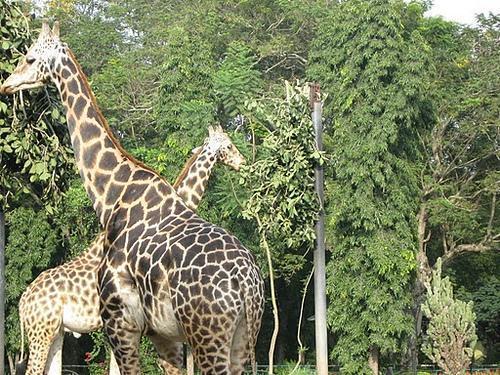How many giraffes are there?
Give a very brief answer. 2. How many food poles for the giraffes are there?
Give a very brief answer. 2. 